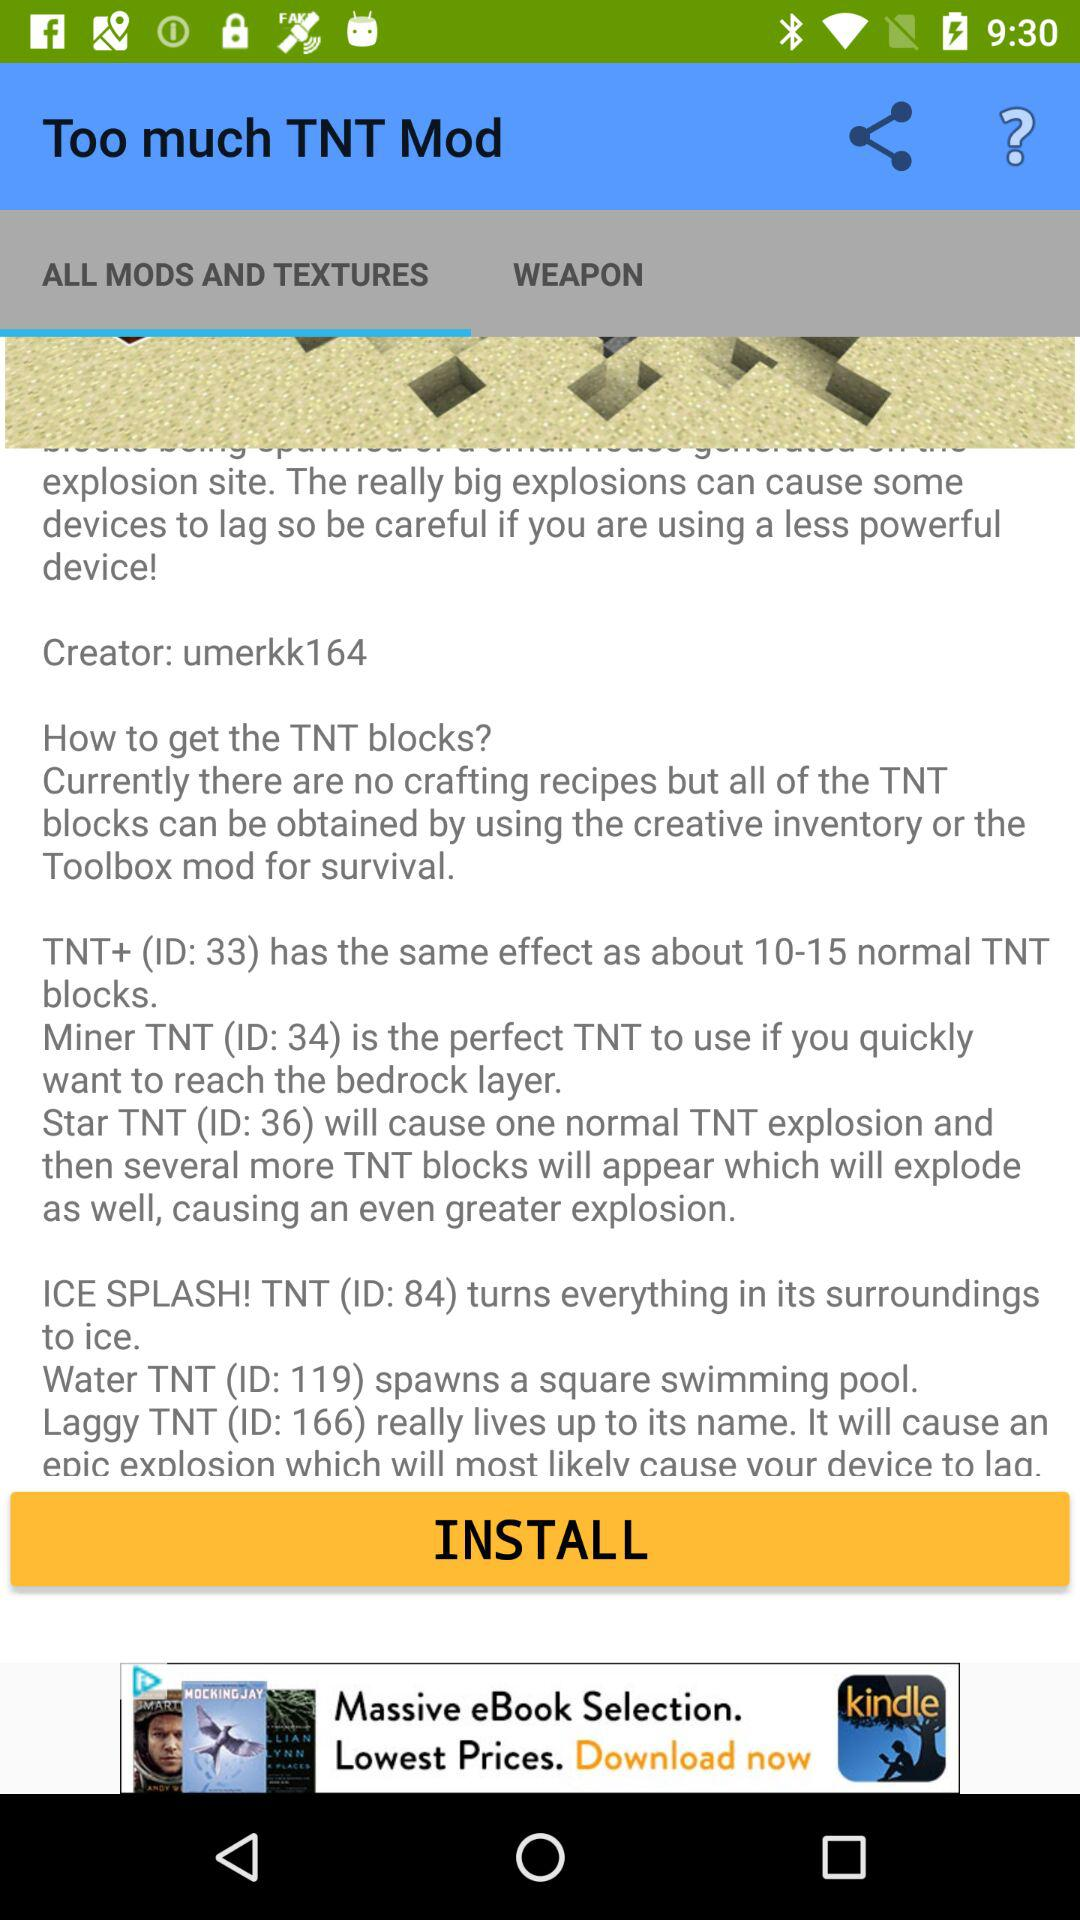Which tab is selected? The selected tab is "ALL MODS AND TEXTURES". 